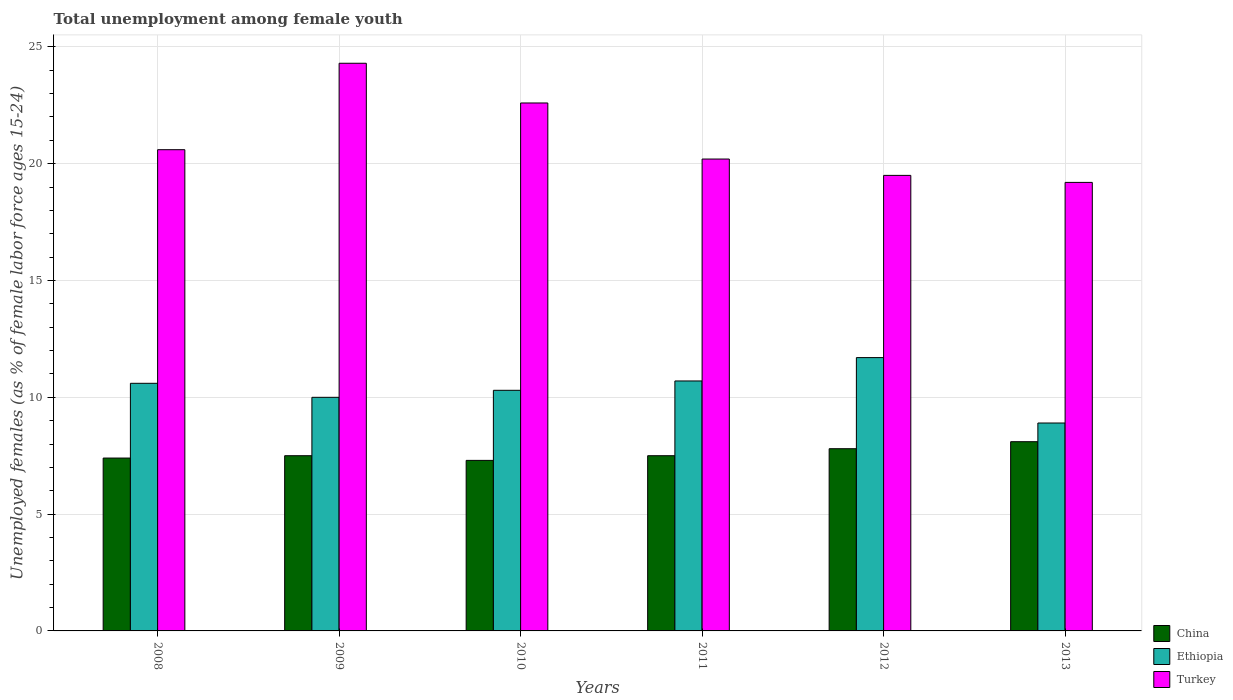How many different coloured bars are there?
Offer a very short reply. 3. Are the number of bars on each tick of the X-axis equal?
Make the answer very short. Yes. How many bars are there on the 3rd tick from the left?
Provide a succinct answer. 3. How many bars are there on the 4th tick from the right?
Your answer should be compact. 3. What is the label of the 1st group of bars from the left?
Provide a succinct answer. 2008. In how many cases, is the number of bars for a given year not equal to the number of legend labels?
Keep it short and to the point. 0. What is the percentage of unemployed females in in Turkey in 2010?
Keep it short and to the point. 22.6. Across all years, what is the maximum percentage of unemployed females in in Ethiopia?
Offer a very short reply. 11.7. Across all years, what is the minimum percentage of unemployed females in in Turkey?
Offer a very short reply. 19.2. In which year was the percentage of unemployed females in in China maximum?
Your response must be concise. 2013. In which year was the percentage of unemployed females in in Ethiopia minimum?
Make the answer very short. 2013. What is the total percentage of unemployed females in in Ethiopia in the graph?
Your answer should be compact. 62.2. What is the difference between the percentage of unemployed females in in Ethiopia in 2009 and that in 2012?
Make the answer very short. -1.7. What is the difference between the percentage of unemployed females in in Ethiopia in 2011 and the percentage of unemployed females in in Turkey in 2010?
Offer a very short reply. -11.9. What is the average percentage of unemployed females in in China per year?
Give a very brief answer. 7.6. In the year 2011, what is the difference between the percentage of unemployed females in in China and percentage of unemployed females in in Turkey?
Your answer should be compact. -12.7. What is the ratio of the percentage of unemployed females in in Ethiopia in 2009 to that in 2012?
Ensure brevity in your answer.  0.85. Is the percentage of unemployed females in in Turkey in 2008 less than that in 2009?
Ensure brevity in your answer.  Yes. Is the difference between the percentage of unemployed females in in China in 2009 and 2010 greater than the difference between the percentage of unemployed females in in Turkey in 2009 and 2010?
Give a very brief answer. No. What is the difference between the highest and the second highest percentage of unemployed females in in China?
Provide a short and direct response. 0.3. What is the difference between the highest and the lowest percentage of unemployed females in in Ethiopia?
Make the answer very short. 2.8. In how many years, is the percentage of unemployed females in in Ethiopia greater than the average percentage of unemployed females in in Ethiopia taken over all years?
Your answer should be compact. 3. Is it the case that in every year, the sum of the percentage of unemployed females in in Ethiopia and percentage of unemployed females in in Turkey is greater than the percentage of unemployed females in in China?
Provide a short and direct response. Yes. Are all the bars in the graph horizontal?
Offer a terse response. No. Does the graph contain any zero values?
Offer a terse response. No. Where does the legend appear in the graph?
Offer a very short reply. Bottom right. How many legend labels are there?
Make the answer very short. 3. How are the legend labels stacked?
Your answer should be compact. Vertical. What is the title of the graph?
Your response must be concise. Total unemployment among female youth. Does "Other small states" appear as one of the legend labels in the graph?
Provide a succinct answer. No. What is the label or title of the Y-axis?
Ensure brevity in your answer.  Unemployed females (as % of female labor force ages 15-24). What is the Unemployed females (as % of female labor force ages 15-24) of China in 2008?
Make the answer very short. 7.4. What is the Unemployed females (as % of female labor force ages 15-24) of Ethiopia in 2008?
Offer a terse response. 10.6. What is the Unemployed females (as % of female labor force ages 15-24) in Turkey in 2008?
Your answer should be very brief. 20.6. What is the Unemployed females (as % of female labor force ages 15-24) in Ethiopia in 2009?
Keep it short and to the point. 10. What is the Unemployed females (as % of female labor force ages 15-24) in Turkey in 2009?
Provide a succinct answer. 24.3. What is the Unemployed females (as % of female labor force ages 15-24) in China in 2010?
Offer a terse response. 7.3. What is the Unemployed females (as % of female labor force ages 15-24) of Ethiopia in 2010?
Provide a succinct answer. 10.3. What is the Unemployed females (as % of female labor force ages 15-24) in Turkey in 2010?
Keep it short and to the point. 22.6. What is the Unemployed females (as % of female labor force ages 15-24) of Ethiopia in 2011?
Offer a terse response. 10.7. What is the Unemployed females (as % of female labor force ages 15-24) in Turkey in 2011?
Make the answer very short. 20.2. What is the Unemployed females (as % of female labor force ages 15-24) in China in 2012?
Your response must be concise. 7.8. What is the Unemployed females (as % of female labor force ages 15-24) of Ethiopia in 2012?
Offer a terse response. 11.7. What is the Unemployed females (as % of female labor force ages 15-24) of China in 2013?
Make the answer very short. 8.1. What is the Unemployed females (as % of female labor force ages 15-24) in Ethiopia in 2013?
Give a very brief answer. 8.9. What is the Unemployed females (as % of female labor force ages 15-24) of Turkey in 2013?
Provide a succinct answer. 19.2. Across all years, what is the maximum Unemployed females (as % of female labor force ages 15-24) of China?
Offer a terse response. 8.1. Across all years, what is the maximum Unemployed females (as % of female labor force ages 15-24) of Ethiopia?
Offer a very short reply. 11.7. Across all years, what is the maximum Unemployed females (as % of female labor force ages 15-24) in Turkey?
Your response must be concise. 24.3. Across all years, what is the minimum Unemployed females (as % of female labor force ages 15-24) in China?
Offer a very short reply. 7.3. Across all years, what is the minimum Unemployed females (as % of female labor force ages 15-24) of Ethiopia?
Your answer should be very brief. 8.9. Across all years, what is the minimum Unemployed females (as % of female labor force ages 15-24) of Turkey?
Keep it short and to the point. 19.2. What is the total Unemployed females (as % of female labor force ages 15-24) of China in the graph?
Provide a succinct answer. 45.6. What is the total Unemployed females (as % of female labor force ages 15-24) in Ethiopia in the graph?
Provide a succinct answer. 62.2. What is the total Unemployed females (as % of female labor force ages 15-24) of Turkey in the graph?
Give a very brief answer. 126.4. What is the difference between the Unemployed females (as % of female labor force ages 15-24) of Ethiopia in 2008 and that in 2010?
Offer a terse response. 0.3. What is the difference between the Unemployed females (as % of female labor force ages 15-24) of Turkey in 2008 and that in 2010?
Keep it short and to the point. -2. What is the difference between the Unemployed females (as % of female labor force ages 15-24) in Ethiopia in 2008 and that in 2011?
Offer a terse response. -0.1. What is the difference between the Unemployed females (as % of female labor force ages 15-24) in Ethiopia in 2008 and that in 2012?
Your response must be concise. -1.1. What is the difference between the Unemployed females (as % of female labor force ages 15-24) in Turkey in 2008 and that in 2012?
Your answer should be compact. 1.1. What is the difference between the Unemployed females (as % of female labor force ages 15-24) in Turkey in 2008 and that in 2013?
Keep it short and to the point. 1.4. What is the difference between the Unemployed females (as % of female labor force ages 15-24) in China in 2009 and that in 2010?
Your response must be concise. 0.2. What is the difference between the Unemployed females (as % of female labor force ages 15-24) of Turkey in 2009 and that in 2011?
Ensure brevity in your answer.  4.1. What is the difference between the Unemployed females (as % of female labor force ages 15-24) of Ethiopia in 2009 and that in 2012?
Ensure brevity in your answer.  -1.7. What is the difference between the Unemployed females (as % of female labor force ages 15-24) of Ethiopia in 2009 and that in 2013?
Provide a short and direct response. 1.1. What is the difference between the Unemployed females (as % of female labor force ages 15-24) of China in 2010 and that in 2011?
Provide a short and direct response. -0.2. What is the difference between the Unemployed females (as % of female labor force ages 15-24) in Ethiopia in 2010 and that in 2011?
Offer a terse response. -0.4. What is the difference between the Unemployed females (as % of female labor force ages 15-24) of Turkey in 2010 and that in 2012?
Your answer should be compact. 3.1. What is the difference between the Unemployed females (as % of female labor force ages 15-24) in China in 2010 and that in 2013?
Your answer should be compact. -0.8. What is the difference between the Unemployed females (as % of female labor force ages 15-24) in Ethiopia in 2010 and that in 2013?
Offer a terse response. 1.4. What is the difference between the Unemployed females (as % of female labor force ages 15-24) of Ethiopia in 2011 and that in 2012?
Provide a short and direct response. -1. What is the difference between the Unemployed females (as % of female labor force ages 15-24) in China in 2011 and that in 2013?
Provide a succinct answer. -0.6. What is the difference between the Unemployed females (as % of female labor force ages 15-24) in Ethiopia in 2011 and that in 2013?
Offer a very short reply. 1.8. What is the difference between the Unemployed females (as % of female labor force ages 15-24) in Turkey in 2011 and that in 2013?
Ensure brevity in your answer.  1. What is the difference between the Unemployed females (as % of female labor force ages 15-24) in China in 2012 and that in 2013?
Offer a terse response. -0.3. What is the difference between the Unemployed females (as % of female labor force ages 15-24) in China in 2008 and the Unemployed females (as % of female labor force ages 15-24) in Ethiopia in 2009?
Make the answer very short. -2.6. What is the difference between the Unemployed females (as % of female labor force ages 15-24) of China in 2008 and the Unemployed females (as % of female labor force ages 15-24) of Turkey in 2009?
Provide a short and direct response. -16.9. What is the difference between the Unemployed females (as % of female labor force ages 15-24) of Ethiopia in 2008 and the Unemployed females (as % of female labor force ages 15-24) of Turkey in 2009?
Provide a succinct answer. -13.7. What is the difference between the Unemployed females (as % of female labor force ages 15-24) in China in 2008 and the Unemployed females (as % of female labor force ages 15-24) in Turkey in 2010?
Your answer should be compact. -15.2. What is the difference between the Unemployed females (as % of female labor force ages 15-24) in Ethiopia in 2008 and the Unemployed females (as % of female labor force ages 15-24) in Turkey in 2010?
Offer a terse response. -12. What is the difference between the Unemployed females (as % of female labor force ages 15-24) of China in 2008 and the Unemployed females (as % of female labor force ages 15-24) of Turkey in 2011?
Your response must be concise. -12.8. What is the difference between the Unemployed females (as % of female labor force ages 15-24) of Ethiopia in 2008 and the Unemployed females (as % of female labor force ages 15-24) of Turkey in 2011?
Ensure brevity in your answer.  -9.6. What is the difference between the Unemployed females (as % of female labor force ages 15-24) of China in 2008 and the Unemployed females (as % of female labor force ages 15-24) of Ethiopia in 2013?
Give a very brief answer. -1.5. What is the difference between the Unemployed females (as % of female labor force ages 15-24) in China in 2008 and the Unemployed females (as % of female labor force ages 15-24) in Turkey in 2013?
Keep it short and to the point. -11.8. What is the difference between the Unemployed females (as % of female labor force ages 15-24) in China in 2009 and the Unemployed females (as % of female labor force ages 15-24) in Ethiopia in 2010?
Ensure brevity in your answer.  -2.8. What is the difference between the Unemployed females (as % of female labor force ages 15-24) in China in 2009 and the Unemployed females (as % of female labor force ages 15-24) in Turkey in 2010?
Make the answer very short. -15.1. What is the difference between the Unemployed females (as % of female labor force ages 15-24) in China in 2009 and the Unemployed females (as % of female labor force ages 15-24) in Turkey in 2011?
Make the answer very short. -12.7. What is the difference between the Unemployed females (as % of female labor force ages 15-24) of China in 2009 and the Unemployed females (as % of female labor force ages 15-24) of Turkey in 2013?
Provide a succinct answer. -11.7. What is the difference between the Unemployed females (as % of female labor force ages 15-24) in China in 2010 and the Unemployed females (as % of female labor force ages 15-24) in Ethiopia in 2011?
Your response must be concise. -3.4. What is the difference between the Unemployed females (as % of female labor force ages 15-24) in Ethiopia in 2010 and the Unemployed females (as % of female labor force ages 15-24) in Turkey in 2012?
Your response must be concise. -9.2. What is the difference between the Unemployed females (as % of female labor force ages 15-24) in China in 2010 and the Unemployed females (as % of female labor force ages 15-24) in Turkey in 2013?
Offer a terse response. -11.9. What is the difference between the Unemployed females (as % of female labor force ages 15-24) of Ethiopia in 2010 and the Unemployed females (as % of female labor force ages 15-24) of Turkey in 2013?
Provide a succinct answer. -8.9. What is the difference between the Unemployed females (as % of female labor force ages 15-24) of China in 2011 and the Unemployed females (as % of female labor force ages 15-24) of Ethiopia in 2012?
Provide a succinct answer. -4.2. What is the difference between the Unemployed females (as % of female labor force ages 15-24) in China in 2011 and the Unemployed females (as % of female labor force ages 15-24) in Turkey in 2012?
Offer a terse response. -12. What is the difference between the Unemployed females (as % of female labor force ages 15-24) of Ethiopia in 2011 and the Unemployed females (as % of female labor force ages 15-24) of Turkey in 2012?
Ensure brevity in your answer.  -8.8. What is the difference between the Unemployed females (as % of female labor force ages 15-24) of China in 2012 and the Unemployed females (as % of female labor force ages 15-24) of Turkey in 2013?
Provide a succinct answer. -11.4. What is the average Unemployed females (as % of female labor force ages 15-24) in China per year?
Provide a succinct answer. 7.6. What is the average Unemployed females (as % of female labor force ages 15-24) of Ethiopia per year?
Give a very brief answer. 10.37. What is the average Unemployed females (as % of female labor force ages 15-24) of Turkey per year?
Your answer should be very brief. 21.07. In the year 2009, what is the difference between the Unemployed females (as % of female labor force ages 15-24) in China and Unemployed females (as % of female labor force ages 15-24) in Turkey?
Keep it short and to the point. -16.8. In the year 2009, what is the difference between the Unemployed females (as % of female labor force ages 15-24) in Ethiopia and Unemployed females (as % of female labor force ages 15-24) in Turkey?
Provide a short and direct response. -14.3. In the year 2010, what is the difference between the Unemployed females (as % of female labor force ages 15-24) in China and Unemployed females (as % of female labor force ages 15-24) in Turkey?
Make the answer very short. -15.3. In the year 2010, what is the difference between the Unemployed females (as % of female labor force ages 15-24) in Ethiopia and Unemployed females (as % of female labor force ages 15-24) in Turkey?
Your response must be concise. -12.3. In the year 2011, what is the difference between the Unemployed females (as % of female labor force ages 15-24) of China and Unemployed females (as % of female labor force ages 15-24) of Turkey?
Ensure brevity in your answer.  -12.7. In the year 2013, what is the difference between the Unemployed females (as % of female labor force ages 15-24) of China and Unemployed females (as % of female labor force ages 15-24) of Ethiopia?
Your answer should be very brief. -0.8. In the year 2013, what is the difference between the Unemployed females (as % of female labor force ages 15-24) of China and Unemployed females (as % of female labor force ages 15-24) of Turkey?
Offer a terse response. -11.1. In the year 2013, what is the difference between the Unemployed females (as % of female labor force ages 15-24) of Ethiopia and Unemployed females (as % of female labor force ages 15-24) of Turkey?
Your response must be concise. -10.3. What is the ratio of the Unemployed females (as % of female labor force ages 15-24) in China in 2008 to that in 2009?
Keep it short and to the point. 0.99. What is the ratio of the Unemployed females (as % of female labor force ages 15-24) in Ethiopia in 2008 to that in 2009?
Ensure brevity in your answer.  1.06. What is the ratio of the Unemployed females (as % of female labor force ages 15-24) of Turkey in 2008 to that in 2009?
Offer a very short reply. 0.85. What is the ratio of the Unemployed females (as % of female labor force ages 15-24) of China in 2008 to that in 2010?
Offer a terse response. 1.01. What is the ratio of the Unemployed females (as % of female labor force ages 15-24) in Ethiopia in 2008 to that in 2010?
Offer a very short reply. 1.03. What is the ratio of the Unemployed females (as % of female labor force ages 15-24) in Turkey in 2008 to that in 2010?
Make the answer very short. 0.91. What is the ratio of the Unemployed females (as % of female labor force ages 15-24) of China in 2008 to that in 2011?
Provide a succinct answer. 0.99. What is the ratio of the Unemployed females (as % of female labor force ages 15-24) in Ethiopia in 2008 to that in 2011?
Provide a succinct answer. 0.99. What is the ratio of the Unemployed females (as % of female labor force ages 15-24) of Turkey in 2008 to that in 2011?
Offer a very short reply. 1.02. What is the ratio of the Unemployed females (as % of female labor force ages 15-24) in China in 2008 to that in 2012?
Make the answer very short. 0.95. What is the ratio of the Unemployed females (as % of female labor force ages 15-24) of Ethiopia in 2008 to that in 2012?
Keep it short and to the point. 0.91. What is the ratio of the Unemployed females (as % of female labor force ages 15-24) of Turkey in 2008 to that in 2012?
Offer a very short reply. 1.06. What is the ratio of the Unemployed females (as % of female labor force ages 15-24) in China in 2008 to that in 2013?
Offer a very short reply. 0.91. What is the ratio of the Unemployed females (as % of female labor force ages 15-24) of Ethiopia in 2008 to that in 2013?
Your answer should be compact. 1.19. What is the ratio of the Unemployed females (as % of female labor force ages 15-24) in Turkey in 2008 to that in 2013?
Your answer should be compact. 1.07. What is the ratio of the Unemployed females (as % of female labor force ages 15-24) in China in 2009 to that in 2010?
Offer a very short reply. 1.03. What is the ratio of the Unemployed females (as % of female labor force ages 15-24) of Ethiopia in 2009 to that in 2010?
Your response must be concise. 0.97. What is the ratio of the Unemployed females (as % of female labor force ages 15-24) in Turkey in 2009 to that in 2010?
Provide a short and direct response. 1.08. What is the ratio of the Unemployed females (as % of female labor force ages 15-24) in Ethiopia in 2009 to that in 2011?
Keep it short and to the point. 0.93. What is the ratio of the Unemployed females (as % of female labor force ages 15-24) in Turkey in 2009 to that in 2011?
Offer a very short reply. 1.2. What is the ratio of the Unemployed females (as % of female labor force ages 15-24) in China in 2009 to that in 2012?
Offer a very short reply. 0.96. What is the ratio of the Unemployed females (as % of female labor force ages 15-24) in Ethiopia in 2009 to that in 2012?
Make the answer very short. 0.85. What is the ratio of the Unemployed females (as % of female labor force ages 15-24) in Turkey in 2009 to that in 2012?
Your response must be concise. 1.25. What is the ratio of the Unemployed females (as % of female labor force ages 15-24) of China in 2009 to that in 2013?
Keep it short and to the point. 0.93. What is the ratio of the Unemployed females (as % of female labor force ages 15-24) of Ethiopia in 2009 to that in 2013?
Provide a succinct answer. 1.12. What is the ratio of the Unemployed females (as % of female labor force ages 15-24) of Turkey in 2009 to that in 2013?
Make the answer very short. 1.27. What is the ratio of the Unemployed females (as % of female labor force ages 15-24) in China in 2010 to that in 2011?
Offer a terse response. 0.97. What is the ratio of the Unemployed females (as % of female labor force ages 15-24) in Ethiopia in 2010 to that in 2011?
Offer a very short reply. 0.96. What is the ratio of the Unemployed females (as % of female labor force ages 15-24) in Turkey in 2010 to that in 2011?
Ensure brevity in your answer.  1.12. What is the ratio of the Unemployed females (as % of female labor force ages 15-24) in China in 2010 to that in 2012?
Provide a short and direct response. 0.94. What is the ratio of the Unemployed females (as % of female labor force ages 15-24) of Ethiopia in 2010 to that in 2012?
Ensure brevity in your answer.  0.88. What is the ratio of the Unemployed females (as % of female labor force ages 15-24) of Turkey in 2010 to that in 2012?
Make the answer very short. 1.16. What is the ratio of the Unemployed females (as % of female labor force ages 15-24) in China in 2010 to that in 2013?
Provide a succinct answer. 0.9. What is the ratio of the Unemployed females (as % of female labor force ages 15-24) in Ethiopia in 2010 to that in 2013?
Offer a very short reply. 1.16. What is the ratio of the Unemployed females (as % of female labor force ages 15-24) in Turkey in 2010 to that in 2013?
Your response must be concise. 1.18. What is the ratio of the Unemployed females (as % of female labor force ages 15-24) of China in 2011 to that in 2012?
Keep it short and to the point. 0.96. What is the ratio of the Unemployed females (as % of female labor force ages 15-24) of Ethiopia in 2011 to that in 2012?
Your answer should be very brief. 0.91. What is the ratio of the Unemployed females (as % of female labor force ages 15-24) of Turkey in 2011 to that in 2012?
Your answer should be very brief. 1.04. What is the ratio of the Unemployed females (as % of female labor force ages 15-24) in China in 2011 to that in 2013?
Your answer should be compact. 0.93. What is the ratio of the Unemployed females (as % of female labor force ages 15-24) in Ethiopia in 2011 to that in 2013?
Make the answer very short. 1.2. What is the ratio of the Unemployed females (as % of female labor force ages 15-24) in Turkey in 2011 to that in 2013?
Your answer should be very brief. 1.05. What is the ratio of the Unemployed females (as % of female labor force ages 15-24) of China in 2012 to that in 2013?
Make the answer very short. 0.96. What is the ratio of the Unemployed females (as % of female labor force ages 15-24) in Ethiopia in 2012 to that in 2013?
Offer a terse response. 1.31. What is the ratio of the Unemployed females (as % of female labor force ages 15-24) in Turkey in 2012 to that in 2013?
Make the answer very short. 1.02. What is the difference between the highest and the second highest Unemployed females (as % of female labor force ages 15-24) in China?
Your answer should be compact. 0.3. What is the difference between the highest and the lowest Unemployed females (as % of female labor force ages 15-24) of China?
Your answer should be compact. 0.8. What is the difference between the highest and the lowest Unemployed females (as % of female labor force ages 15-24) in Ethiopia?
Your answer should be very brief. 2.8. 